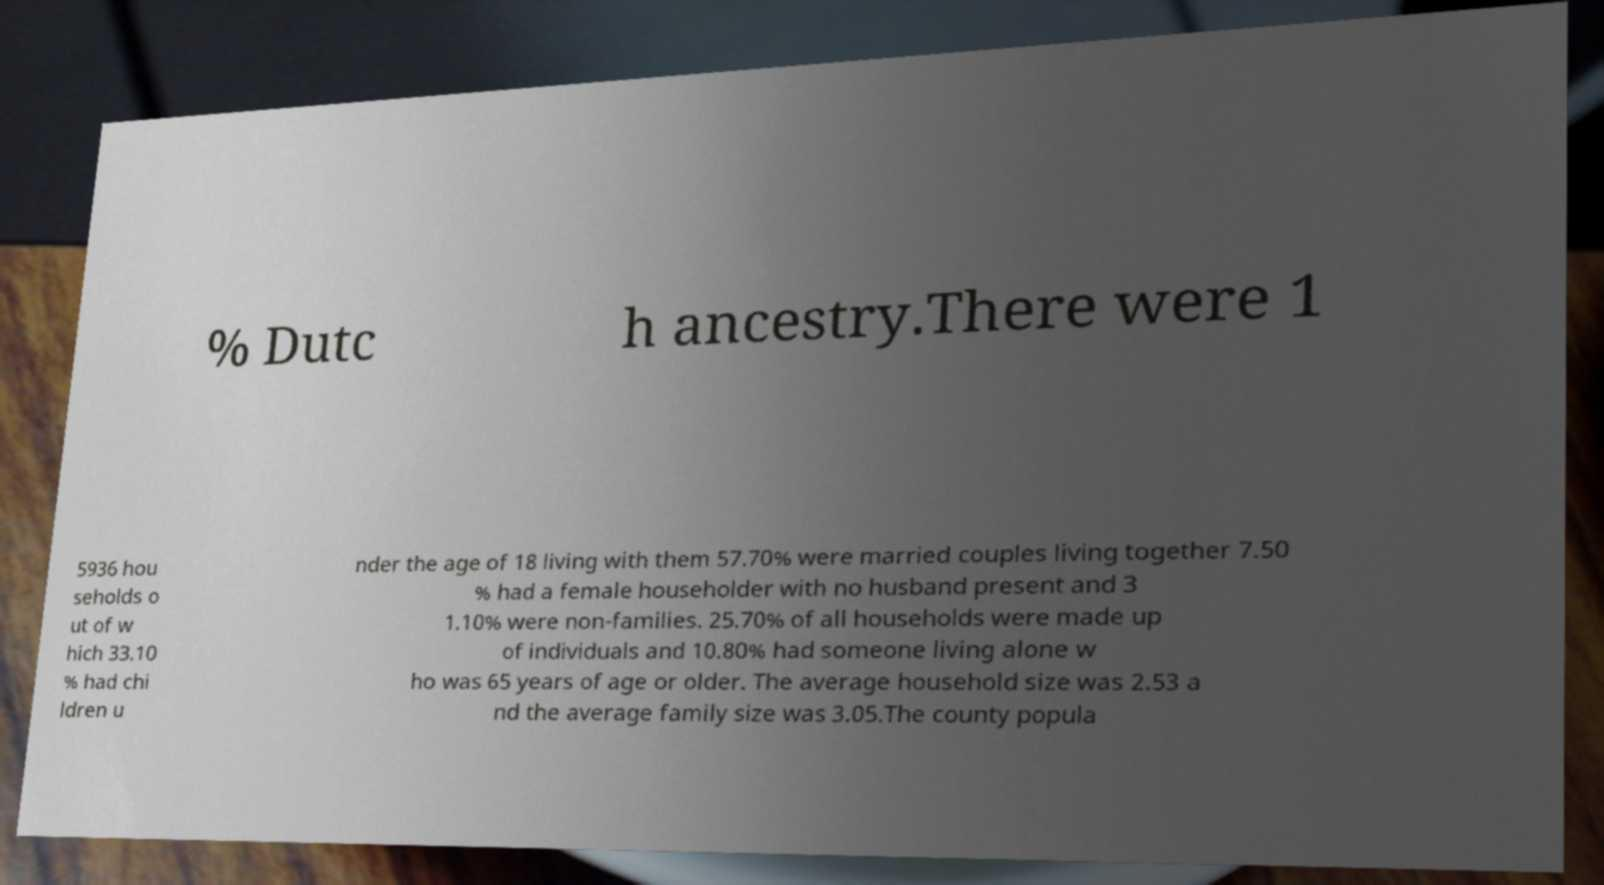Could you extract and type out the text from this image? % Dutc h ancestry.There were 1 5936 hou seholds o ut of w hich 33.10 % had chi ldren u nder the age of 18 living with them 57.70% were married couples living together 7.50 % had a female householder with no husband present and 3 1.10% were non-families. 25.70% of all households were made up of individuals and 10.80% had someone living alone w ho was 65 years of age or older. The average household size was 2.53 a nd the average family size was 3.05.The county popula 